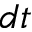Convert formula to latex. <formula><loc_0><loc_0><loc_500><loc_500>d t</formula> 